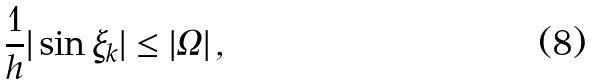<formula> <loc_0><loc_0><loc_500><loc_500>\frac { 1 } { h } | \sin \xi _ { k } | \leq | \Omega | \, ,</formula> 